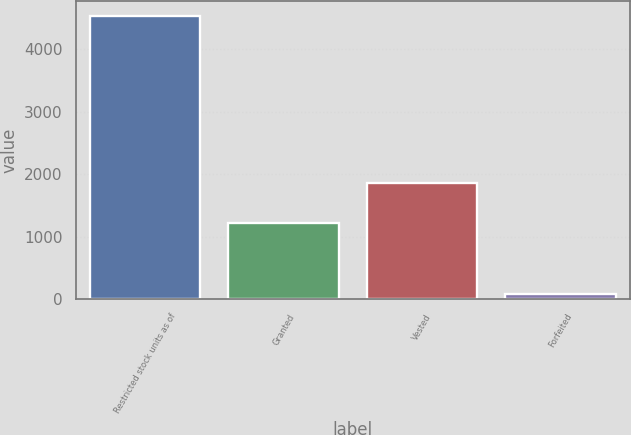Convert chart. <chart><loc_0><loc_0><loc_500><loc_500><bar_chart><fcel>Restricted stock units as of<fcel>Granted<fcel>Vested<fcel>Forfeited<nl><fcel>4539<fcel>1214<fcel>1854<fcel>89<nl></chart> 